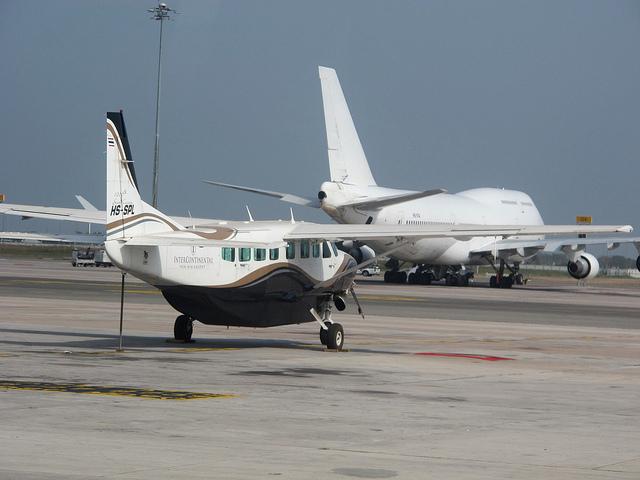Are these airliners?
Be succinct. Yes. How many planes are in the picture?
Concise answer only. 2. Are this cargo planes?
Be succinct. Yes. 